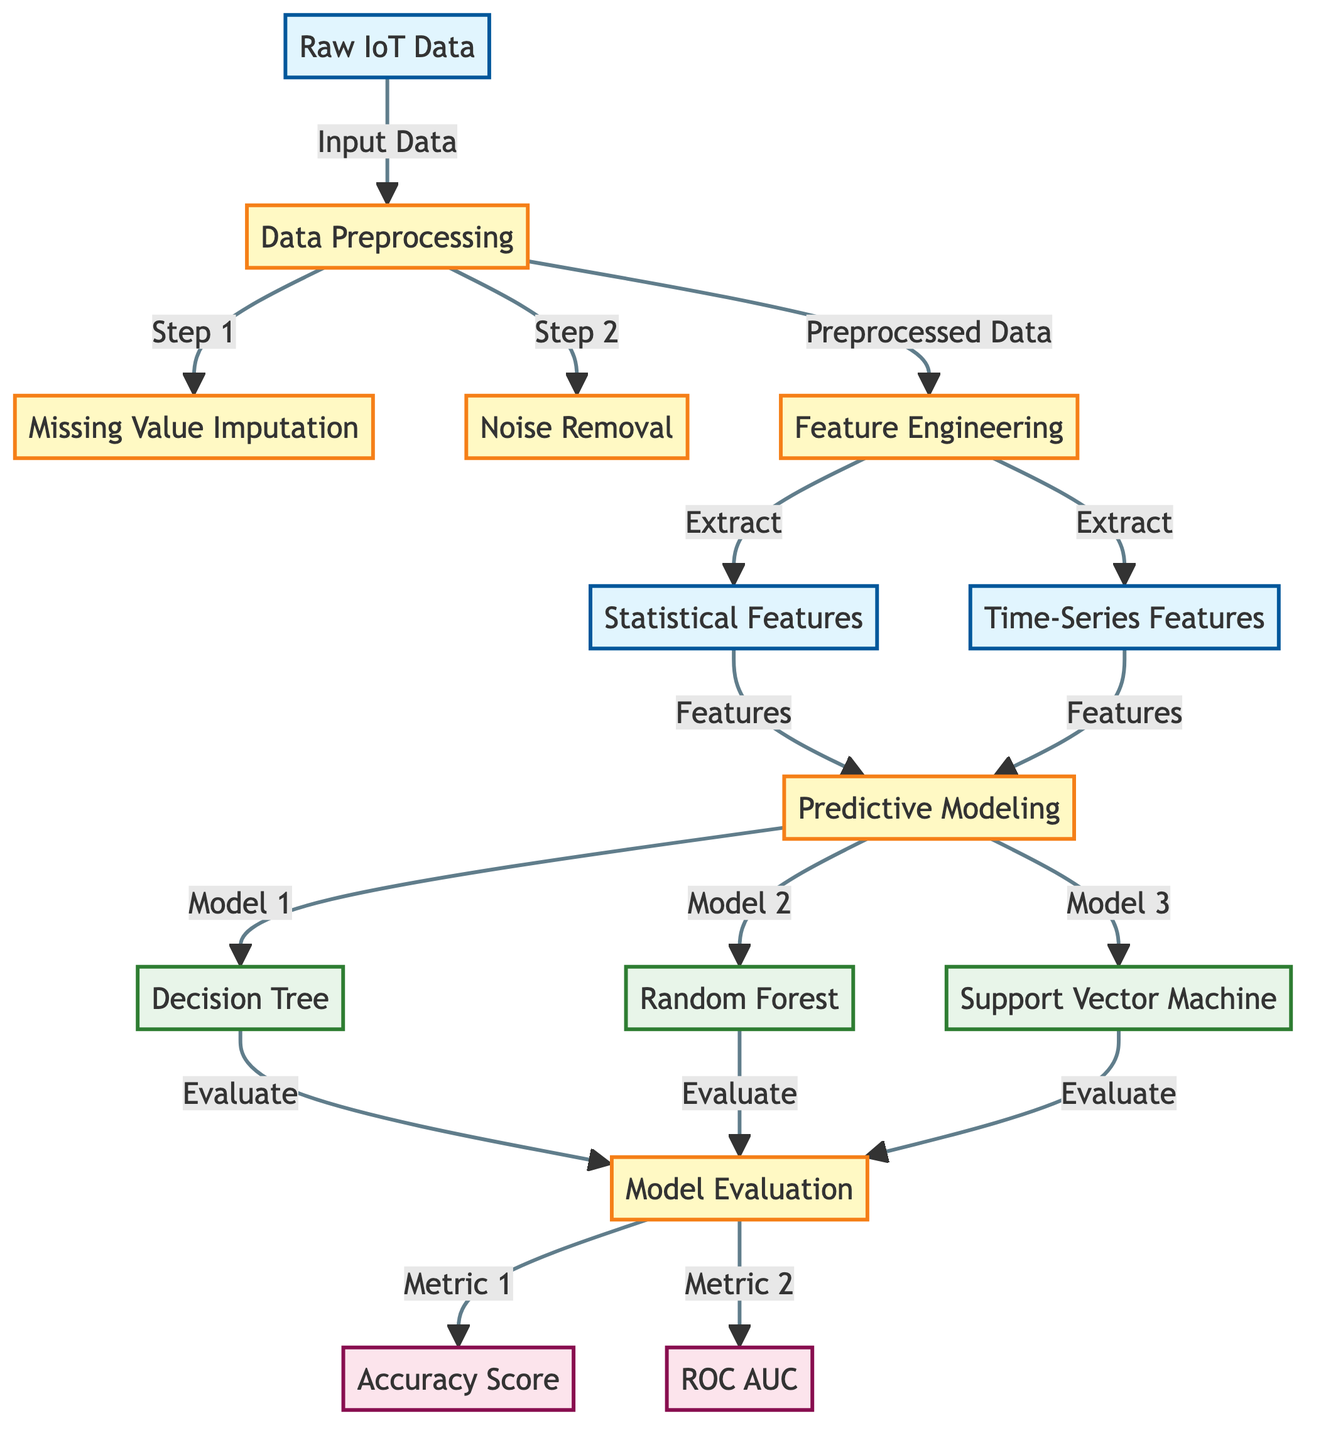What is the first step in the process? The diagram indicates that the first step in the process is "Missing Value Imputation," which follows "Data Preprocessing." Therefore, the first step directly under "Data Preprocessing" is "Missing Value Imputation."
Answer: Missing Value Imputation How many predictive models are illustrated in the diagram? The diagram lists three predictive models: "Decision Tree," "Random Forest," and "Support Vector Machine." Counting these models shows that there are three in total.
Answer: Three Which metrics are used for model evaluation? According to the diagram, the metrics used for model evaluation are "Accuracy Score" and "ROC AUC." These two metrics are directly connected to the "Model Evaluation" node.
Answer: Accuracy Score and ROC AUC What type of features are extracted after feature engineering? From the diagram, "Statistical Features" and "Time-Series Features" are both extracted after the "Feature Engineering" process. Therefore, both types of features are derived during this phase.
Answer: Statistical Features and Time-Series Features Which node follows the "Noise Removal" step? The next node following "Noise Removal" is "Feature Engineering." After "Noise Removal" is completed, the process continues to "Feature Engineering."
Answer: Feature Engineering Which algorithms are used in predictive modeling? The diagram showcases three algorithms mentioned under the "Predictive Modeling" node: "Decision Tree," "Random Forest," and "Support Vector Machine." Thus, these are the algorithms used for prediction.
Answer: Decision Tree, Random Forest, and Support Vector Machine What connects "Statistical Features" and "Time-Series Features" to "Predictive Modeling"? Both "Statistical Features" and "Time-Series Features" connect to the "Predictive Modeling" node, indicating that they serve as inputs or features for the modeling process.
Answer: Features What is the output of the "Model Evaluation" step? The output of the "Model Evaluation" step consists of the metrics, specifically "Accuracy Score" and "ROC AUC." These metrics summarize the results of the evaluation process conducted on the models.
Answer: Accuracy Score and ROC AUC 